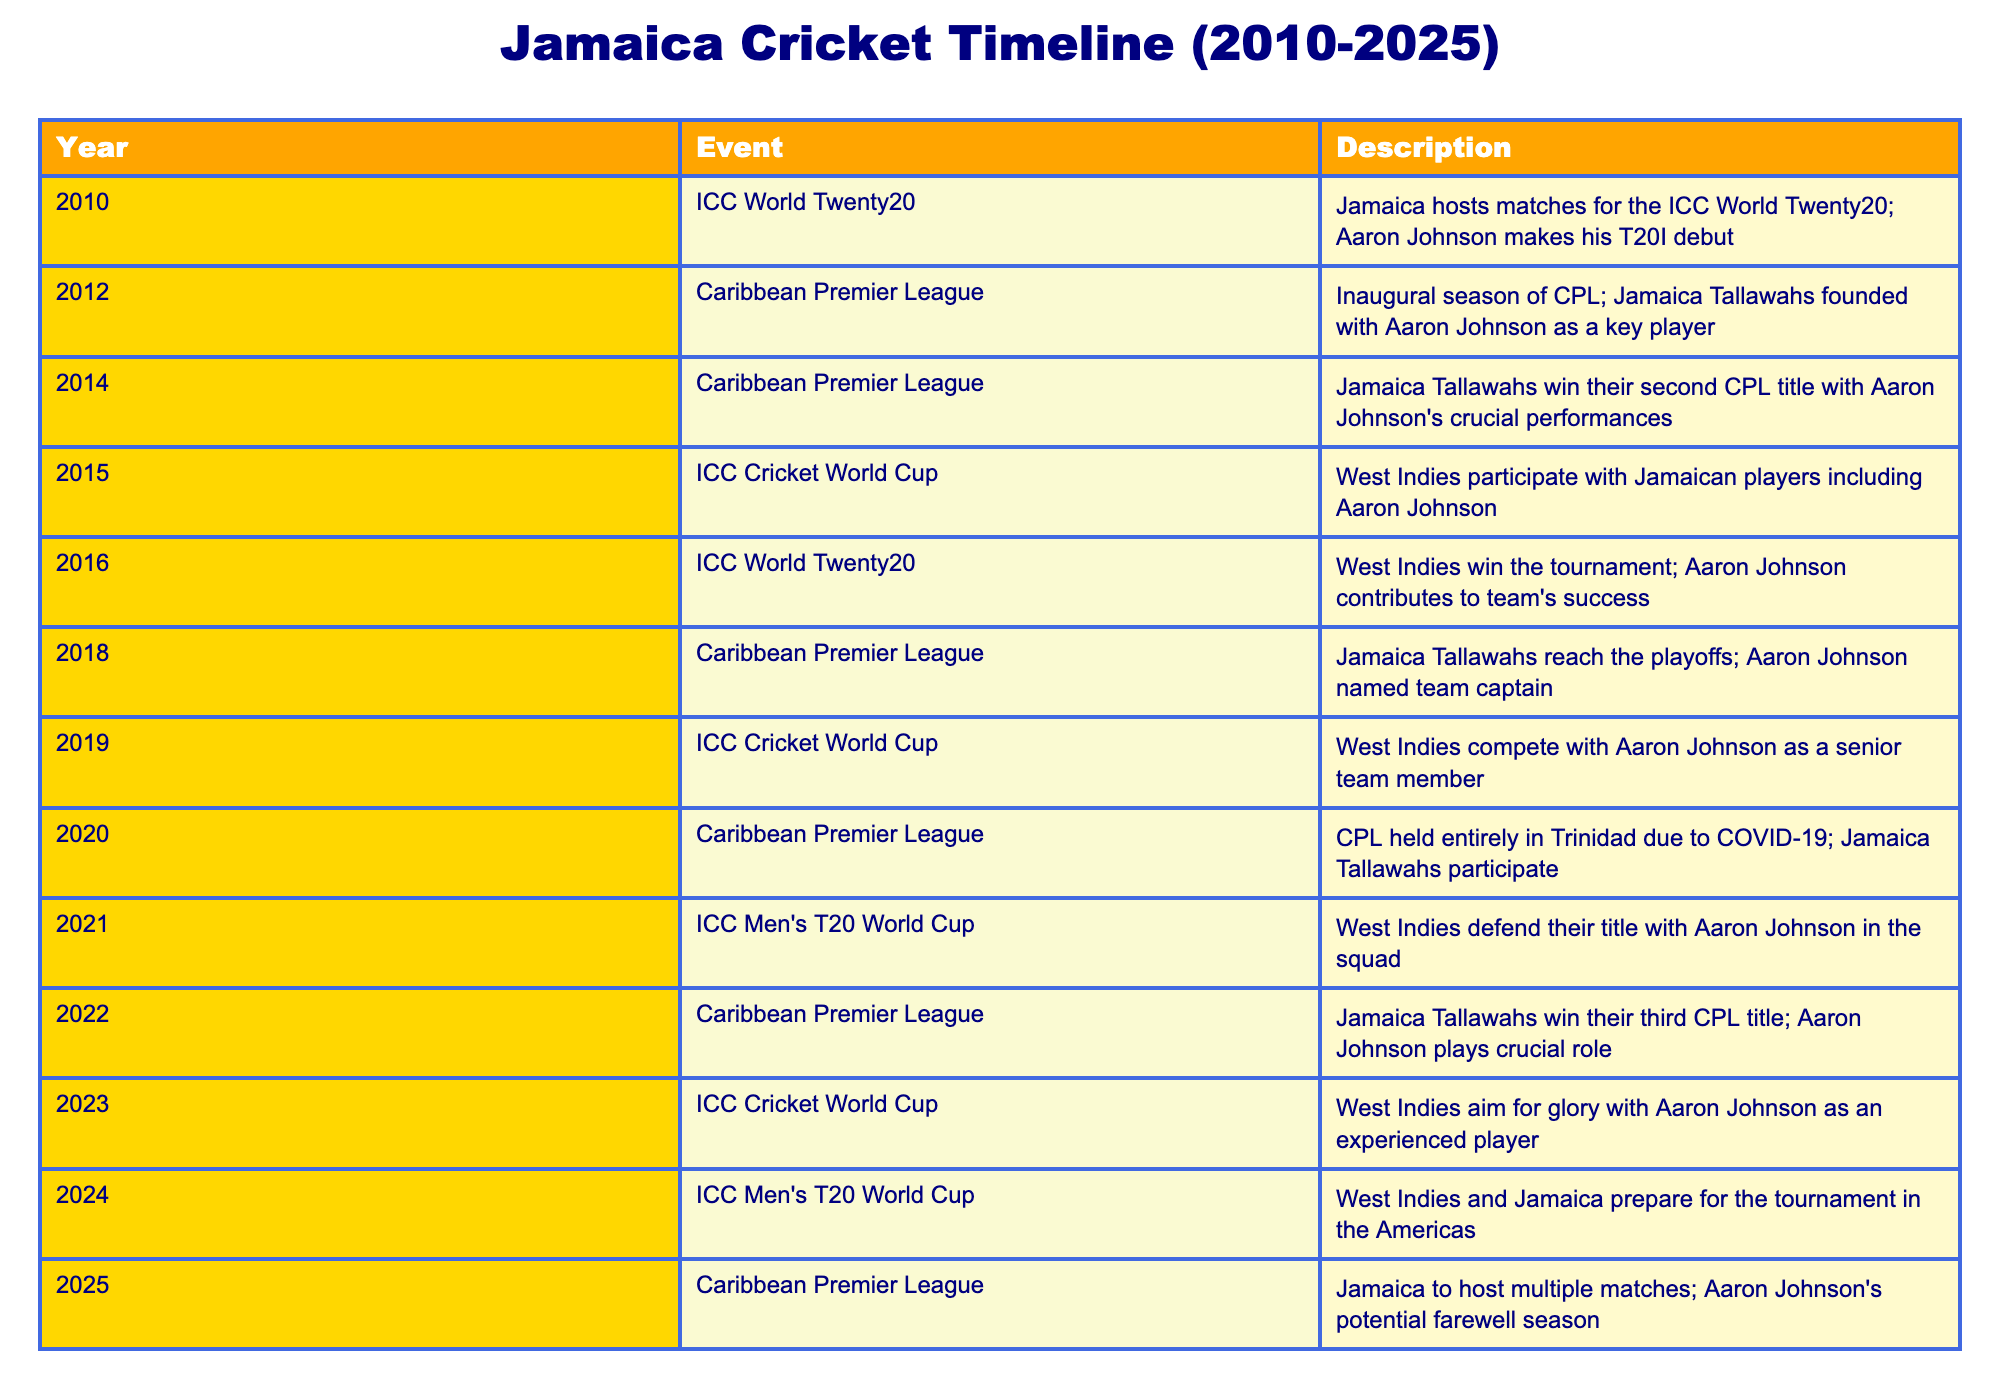What year did Aaron Johnson make his T20I debut? Referring to the table, the event listed for the year 2010 states that Jamaica hosted matches for the ICC World Twenty20 and that Aaron Johnson made his T20I debut that same year.
Answer: 2010 What is the total number of Caribbean Premier League titles won by Jamaica Tallawahs mentioned in the table? The table shows that Jamaica Tallawahs won their second CPL title in 2014 and their third CPL title in 2022. Therefore, they have won 3 titles in total.
Answer: 3 Did Jamaica Tallawahs reach the playoffs in the Caribbean Premier League in 2018? Based on the table, it states that in 2018, Jamaica Tallawahs reached the playoffs. Thus, the answer is yes.
Answer: Yes In how many major tournaments did Aaron Johnson participate between 2015 and 2025? Referring to the table, we identify the years 2015 (ICC Cricket World Cup), 2016 (ICC World Twenty20), 2019 (ICC Cricket World Cup), 2021 (ICC Men's T20 World Cup), 2023 (ICC Cricket World Cup), and anticipate his involvement in the events for the years 2024 and 2025 as well. This results in a total of 7 tournaments.
Answer: 7 What were the consecutive years where West Indies won titles in cricket tournaments that included Aaron Johnson? The table indicates that West Indies won the ICC World Twenty20 in 2016 and the ICC Men's T20 World Cup in 2021. Both years featured Aaron Johnson. Therefore, the consecutive wins occurred in 2016 and 2021.
Answer: 2016 and 2021 In what year did Jamaica Tallawahs win their second CPL title, and who was a key player during that event? According to the table, Jamaica Tallawahs won their second CPL title in 2014, and Aaron Johnson is noted as a key player during that event.
Answer: 2014, Aaron Johnson How many years did Aaron Johnson play in the Caribbean Premier League from 2012 to 2025? From 2012 (the founding year of the Jamaica Tallawahs) to 2025, a total of 14 years is considered, meaning Aaron Johnson participated in the CPL for 14 years if he played every season.
Answer: 14 